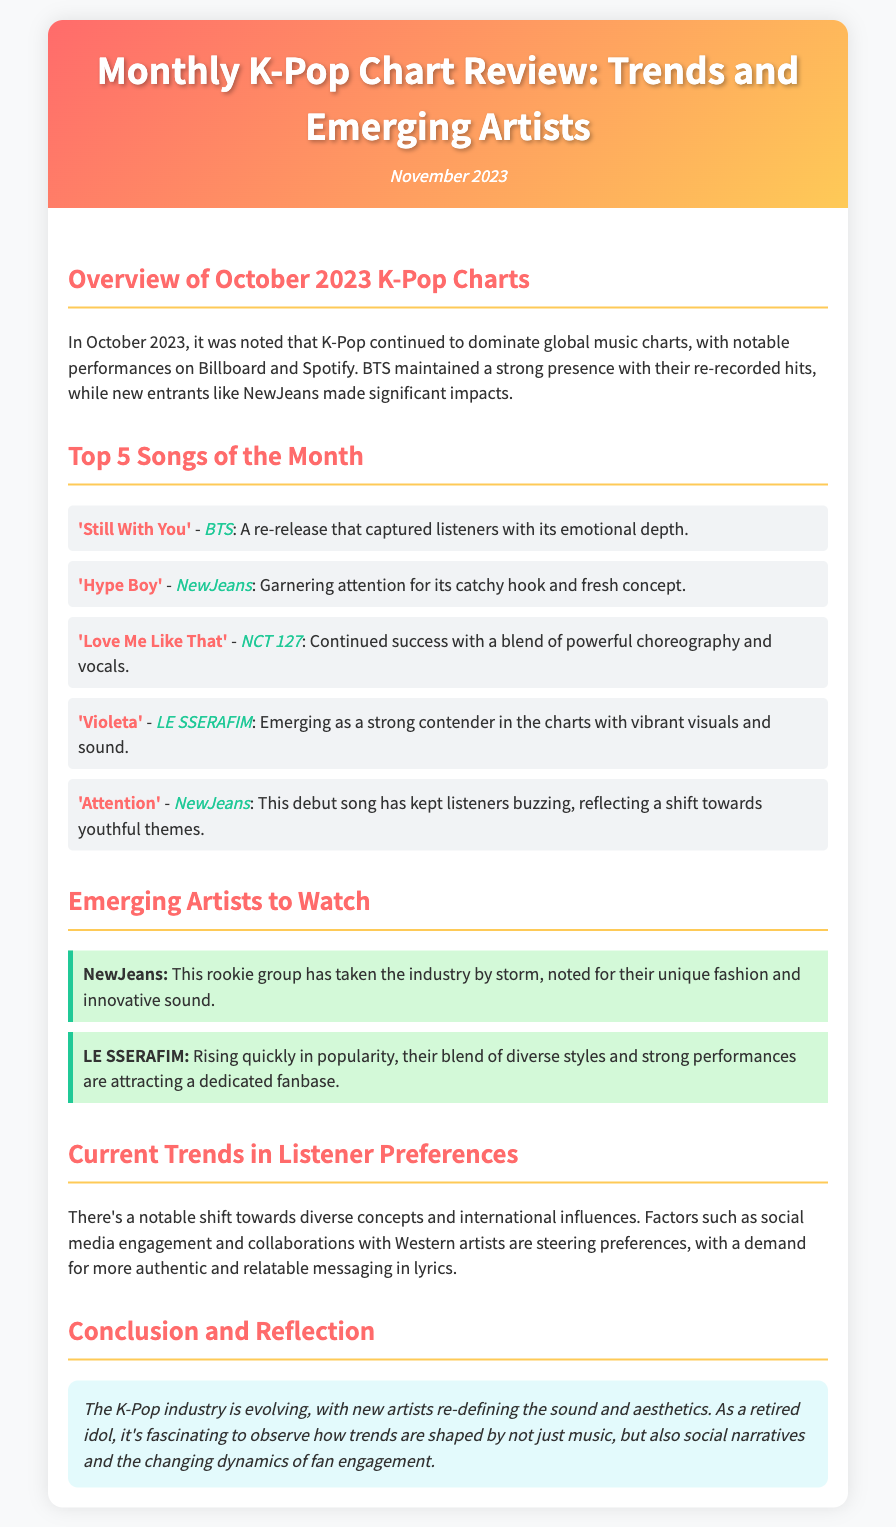What were the top two songs in October 2023? The document lists the top 5 songs, and the first two are 'Still With You' by BTS and 'Hype Boy' by NewJeans.
Answer: 'Still With You', 'Hype Boy' What is the date of this monthly review? The document states that this is the review for November 2023.
Answer: November 2023 Which group is highlighted as an emerging artist in the document? The emerging artists section features NewJeans and LE SSERAFIM as artists to watch.
Answer: NewJeans, LE SSERAFIM What does the document indicate about listener preferences? It mentions a shift towards diverse concepts and the influence of social media and collaborations.
Answer: Diverse concepts, social media influence Who performed the song 'Attention'? The document specifies that 'Attention' is performed by NewJeans.
Answer: NewJeans What is a current trend in K-Pop listener preferences according to the document? The document states that listeners are seeking more authentic and relatable messaging in lyrics.
Answer: Authentic messaging Which group maintained a strong presence with their re-recorded hits? The overview mentions BTS as maintaining a strong presence on the charts.
Answer: BTS What is the conclusion about evolving trends in K-Pop? The conclusion reflects on how new artists are redefining music and fan engagement.
Answer: Redefining sound and aesthetics 